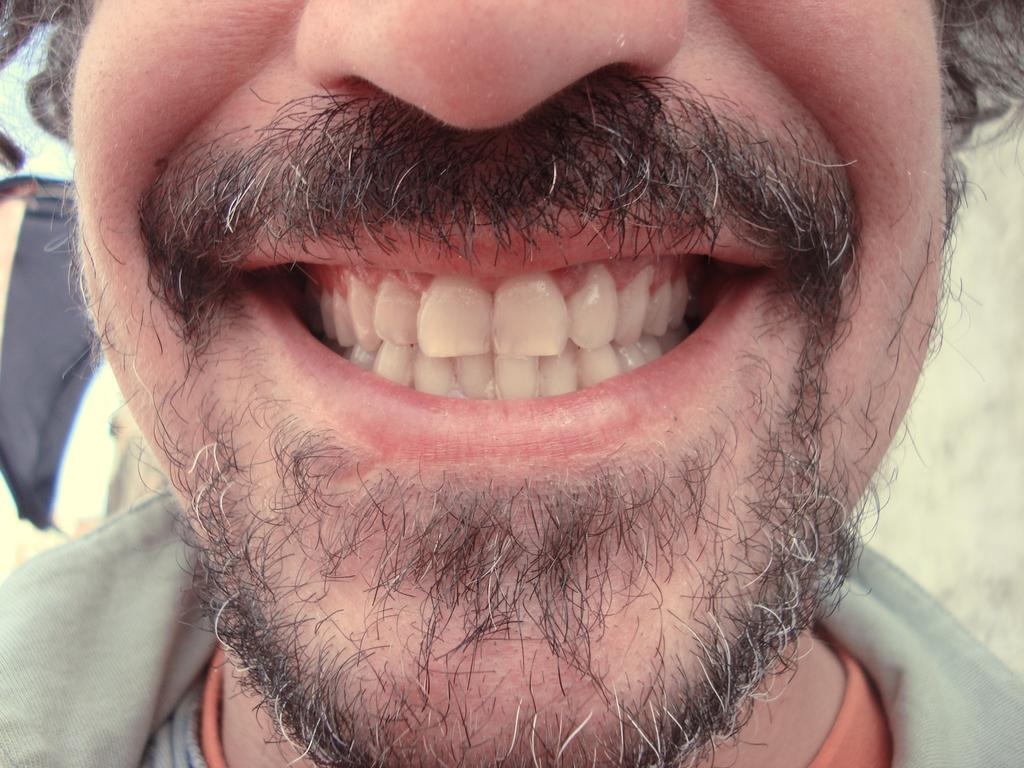What is the main subject of the image? The main subject of the image is a person's teeth. Can you describe the details of the teeth in the image? Unfortunately, the image is a zoomed-in picture, so it's difficult to provide specific details about the teeth. What type of wood is used to construct the division in the image? There is no division present in the image, as it is a zoomed-in picture of a person's teeth. 